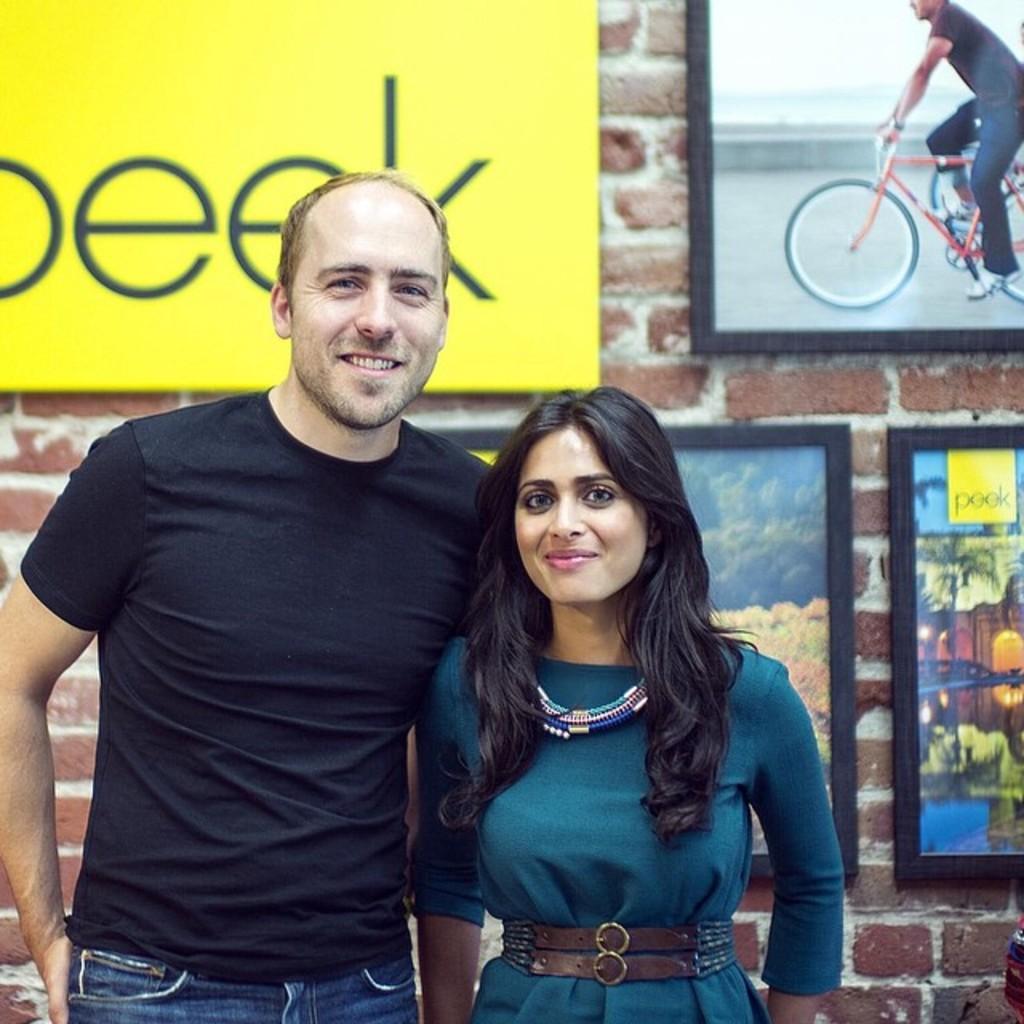Can you describe this image briefly? Here there is a man standing beside a woman. He is wearing a T-Shirt and a woman is wearing a blue color dress. She is smiling behind them there is a brick wall on this wall there are photo frames. 